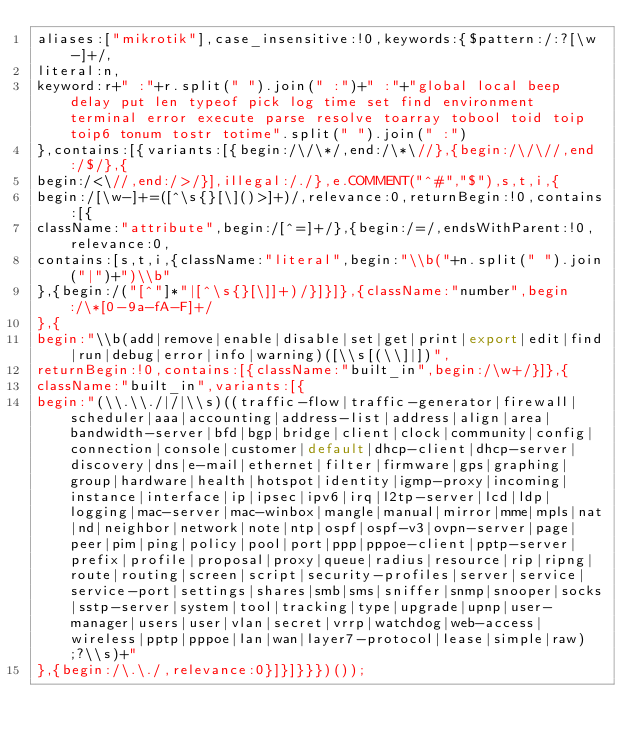<code> <loc_0><loc_0><loc_500><loc_500><_JavaScript_>aliases:["mikrotik"],case_insensitive:!0,keywords:{$pattern:/:?[\w-]+/,
literal:n,
keyword:r+" :"+r.split(" ").join(" :")+" :"+"global local beep delay put len typeof pick log time set find environment terminal error execute parse resolve toarray tobool toid toip toip6 tonum tostr totime".split(" ").join(" :")
},contains:[{variants:[{begin:/\/\*/,end:/\*\//},{begin:/\/\//,end:/$/},{
begin:/<\//,end:/>/}],illegal:/./},e.COMMENT("^#","$"),s,t,i,{
begin:/[\w-]+=([^\s{}[\]()>]+)/,relevance:0,returnBegin:!0,contains:[{
className:"attribute",begin:/[^=]+/},{begin:/=/,endsWithParent:!0,relevance:0,
contains:[s,t,i,{className:"literal",begin:"\\b("+n.split(" ").join("|")+")\\b"
},{begin:/("[^"]*"|[^\s{}[\]]+)/}]}]},{className:"number",begin:/\*[0-9a-fA-F]+/
},{
begin:"\\b(add|remove|enable|disable|set|get|print|export|edit|find|run|debug|error|info|warning)([\\s[(\\]|])",
returnBegin:!0,contains:[{className:"built_in",begin:/\w+/}]},{
className:"built_in",variants:[{
begin:"(\\.\\./|/|\\s)((traffic-flow|traffic-generator|firewall|scheduler|aaa|accounting|address-list|address|align|area|bandwidth-server|bfd|bgp|bridge|client|clock|community|config|connection|console|customer|default|dhcp-client|dhcp-server|discovery|dns|e-mail|ethernet|filter|firmware|gps|graphing|group|hardware|health|hotspot|identity|igmp-proxy|incoming|instance|interface|ip|ipsec|ipv6|irq|l2tp-server|lcd|ldp|logging|mac-server|mac-winbox|mangle|manual|mirror|mme|mpls|nat|nd|neighbor|network|note|ntp|ospf|ospf-v3|ovpn-server|page|peer|pim|ping|policy|pool|port|ppp|pppoe-client|pptp-server|prefix|profile|proposal|proxy|queue|radius|resource|rip|ripng|route|routing|screen|script|security-profiles|server|service|service-port|settings|shares|smb|sms|sniffer|snmp|snooper|socks|sstp-server|system|tool|tracking|type|upgrade|upnp|user-manager|users|user|vlan|secret|vrrp|watchdog|web-access|wireless|pptp|pppoe|lan|wan|layer7-protocol|lease|simple|raw);?\\s)+"
},{begin:/\.\./,relevance:0}]}]}}})());</code> 